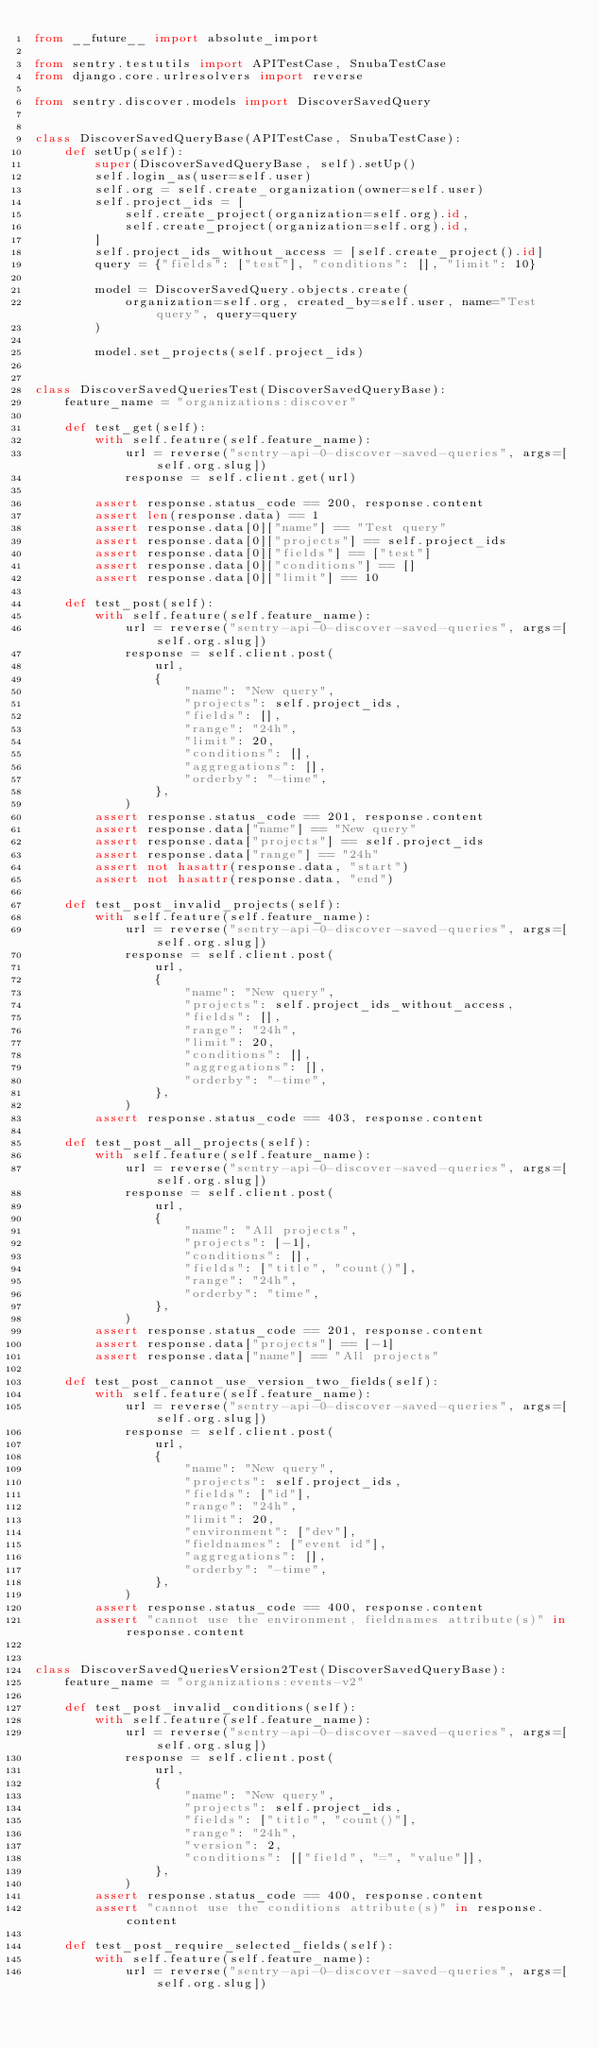Convert code to text. <code><loc_0><loc_0><loc_500><loc_500><_Python_>from __future__ import absolute_import

from sentry.testutils import APITestCase, SnubaTestCase
from django.core.urlresolvers import reverse

from sentry.discover.models import DiscoverSavedQuery


class DiscoverSavedQueryBase(APITestCase, SnubaTestCase):
    def setUp(self):
        super(DiscoverSavedQueryBase, self).setUp()
        self.login_as(user=self.user)
        self.org = self.create_organization(owner=self.user)
        self.project_ids = [
            self.create_project(organization=self.org).id,
            self.create_project(organization=self.org).id,
        ]
        self.project_ids_without_access = [self.create_project().id]
        query = {"fields": ["test"], "conditions": [], "limit": 10}

        model = DiscoverSavedQuery.objects.create(
            organization=self.org, created_by=self.user, name="Test query", query=query
        )

        model.set_projects(self.project_ids)


class DiscoverSavedQueriesTest(DiscoverSavedQueryBase):
    feature_name = "organizations:discover"

    def test_get(self):
        with self.feature(self.feature_name):
            url = reverse("sentry-api-0-discover-saved-queries", args=[self.org.slug])
            response = self.client.get(url)

        assert response.status_code == 200, response.content
        assert len(response.data) == 1
        assert response.data[0]["name"] == "Test query"
        assert response.data[0]["projects"] == self.project_ids
        assert response.data[0]["fields"] == ["test"]
        assert response.data[0]["conditions"] == []
        assert response.data[0]["limit"] == 10

    def test_post(self):
        with self.feature(self.feature_name):
            url = reverse("sentry-api-0-discover-saved-queries", args=[self.org.slug])
            response = self.client.post(
                url,
                {
                    "name": "New query",
                    "projects": self.project_ids,
                    "fields": [],
                    "range": "24h",
                    "limit": 20,
                    "conditions": [],
                    "aggregations": [],
                    "orderby": "-time",
                },
            )
        assert response.status_code == 201, response.content
        assert response.data["name"] == "New query"
        assert response.data["projects"] == self.project_ids
        assert response.data["range"] == "24h"
        assert not hasattr(response.data, "start")
        assert not hasattr(response.data, "end")

    def test_post_invalid_projects(self):
        with self.feature(self.feature_name):
            url = reverse("sentry-api-0-discover-saved-queries", args=[self.org.slug])
            response = self.client.post(
                url,
                {
                    "name": "New query",
                    "projects": self.project_ids_without_access,
                    "fields": [],
                    "range": "24h",
                    "limit": 20,
                    "conditions": [],
                    "aggregations": [],
                    "orderby": "-time",
                },
            )
        assert response.status_code == 403, response.content

    def test_post_all_projects(self):
        with self.feature(self.feature_name):
            url = reverse("sentry-api-0-discover-saved-queries", args=[self.org.slug])
            response = self.client.post(
                url,
                {
                    "name": "All projects",
                    "projects": [-1],
                    "conditions": [],
                    "fields": ["title", "count()"],
                    "range": "24h",
                    "orderby": "time",
                },
            )
        assert response.status_code == 201, response.content
        assert response.data["projects"] == [-1]
        assert response.data["name"] == "All projects"

    def test_post_cannot_use_version_two_fields(self):
        with self.feature(self.feature_name):
            url = reverse("sentry-api-0-discover-saved-queries", args=[self.org.slug])
            response = self.client.post(
                url,
                {
                    "name": "New query",
                    "projects": self.project_ids,
                    "fields": ["id"],
                    "range": "24h",
                    "limit": 20,
                    "environment": ["dev"],
                    "fieldnames": ["event id"],
                    "aggregations": [],
                    "orderby": "-time",
                },
            )
        assert response.status_code == 400, response.content
        assert "cannot use the environment, fieldnames attribute(s)" in response.content


class DiscoverSavedQueriesVersion2Test(DiscoverSavedQueryBase):
    feature_name = "organizations:events-v2"

    def test_post_invalid_conditions(self):
        with self.feature(self.feature_name):
            url = reverse("sentry-api-0-discover-saved-queries", args=[self.org.slug])
            response = self.client.post(
                url,
                {
                    "name": "New query",
                    "projects": self.project_ids,
                    "fields": ["title", "count()"],
                    "range": "24h",
                    "version": 2,
                    "conditions": [["field", "=", "value"]],
                },
            )
        assert response.status_code == 400, response.content
        assert "cannot use the conditions attribute(s)" in response.content

    def test_post_require_selected_fields(self):
        with self.feature(self.feature_name):
            url = reverse("sentry-api-0-discover-saved-queries", args=[self.org.slug])</code> 